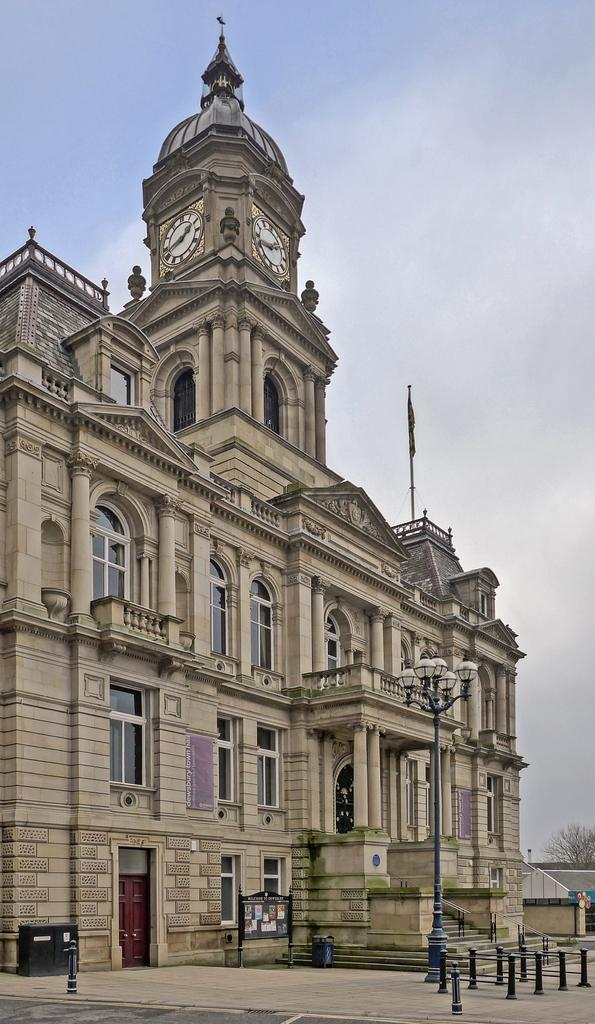What is the main structure in the image? There is a big building in the image. What can be seen in the background of the image? The sky is visible in the background of the image. How many basketballs can be seen in the image? There are no basketballs present in the image. What type of cannon is located on the roof of the building in the image? There is no cannon present on the roof of the building in the image. 